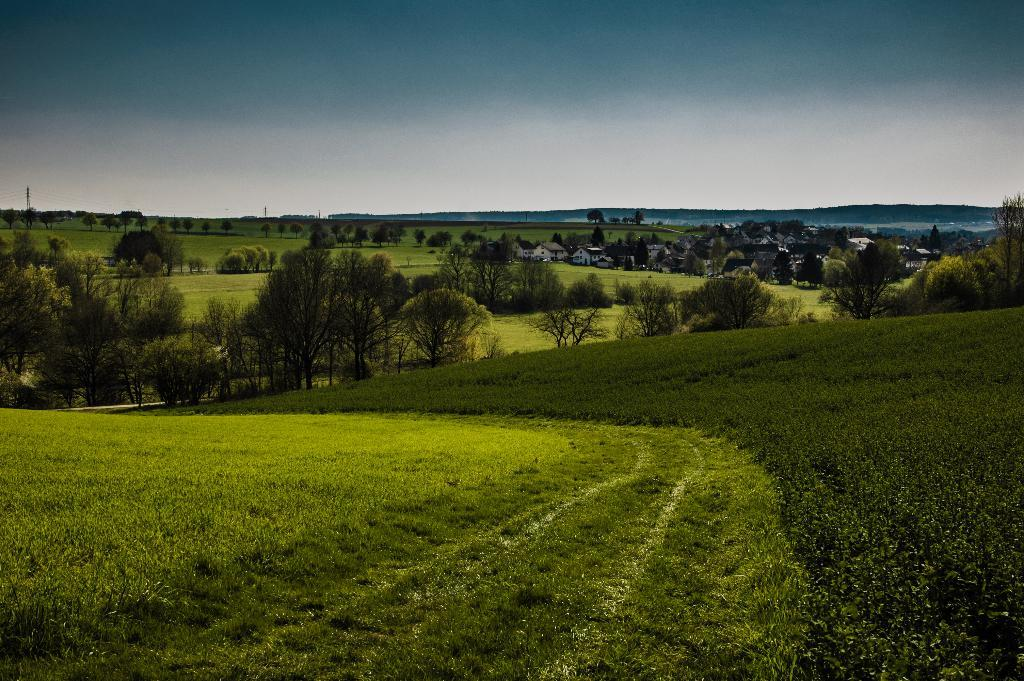What type of structures can be seen in the image? There are houses in the image. What other natural elements are present in the image? There are plants and trees in the image. What is visible in the background of the image? The sky is visible in the image. How many pickles are hanging from the trees in the image? There are no pickles present in the image; it features houses, plants, trees, and the sky. 